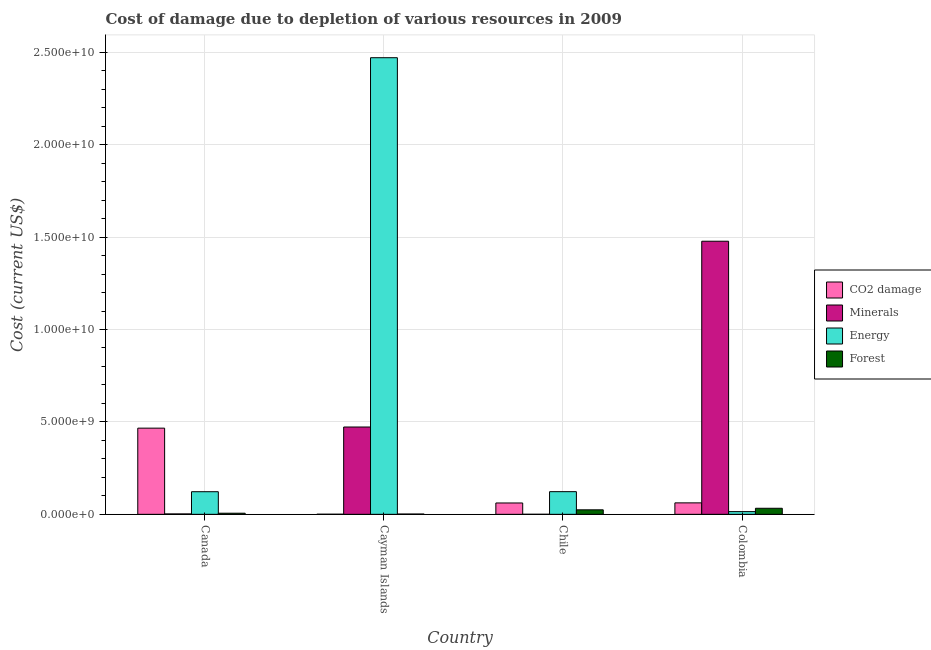Are the number of bars per tick equal to the number of legend labels?
Make the answer very short. Yes. Are the number of bars on each tick of the X-axis equal?
Ensure brevity in your answer.  Yes. How many bars are there on the 1st tick from the right?
Give a very brief answer. 4. What is the label of the 1st group of bars from the left?
Your response must be concise. Canada. What is the cost of damage due to depletion of minerals in Canada?
Your answer should be compact. 2.16e+07. Across all countries, what is the maximum cost of damage due to depletion of minerals?
Provide a short and direct response. 1.48e+1. Across all countries, what is the minimum cost of damage due to depletion of forests?
Offer a very short reply. 1.59e+07. What is the total cost of damage due to depletion of minerals in the graph?
Provide a succinct answer. 1.95e+1. What is the difference between the cost of damage due to depletion of minerals in Canada and that in Cayman Islands?
Your response must be concise. -4.70e+09. What is the difference between the cost of damage due to depletion of minerals in Cayman Islands and the cost of damage due to depletion of energy in Canada?
Your answer should be very brief. 3.50e+09. What is the average cost of damage due to depletion of forests per country?
Offer a terse response. 1.62e+08. What is the difference between the cost of damage due to depletion of energy and cost of damage due to depletion of minerals in Cayman Islands?
Provide a short and direct response. 2.00e+1. What is the ratio of the cost of damage due to depletion of energy in Canada to that in Colombia?
Ensure brevity in your answer.  8.36. What is the difference between the highest and the second highest cost of damage due to depletion of minerals?
Provide a succinct answer. 1.01e+1. What is the difference between the highest and the lowest cost of damage due to depletion of energy?
Offer a terse response. 2.46e+1. In how many countries, is the cost of damage due to depletion of minerals greater than the average cost of damage due to depletion of minerals taken over all countries?
Offer a terse response. 1. Is the sum of the cost of damage due to depletion of coal in Canada and Colombia greater than the maximum cost of damage due to depletion of minerals across all countries?
Provide a succinct answer. No. Is it the case that in every country, the sum of the cost of damage due to depletion of minerals and cost of damage due to depletion of coal is greater than the sum of cost of damage due to depletion of energy and cost of damage due to depletion of forests?
Your response must be concise. Yes. What does the 4th bar from the left in Chile represents?
Offer a terse response. Forest. What does the 3rd bar from the right in Canada represents?
Your answer should be compact. Minerals. Is it the case that in every country, the sum of the cost of damage due to depletion of coal and cost of damage due to depletion of minerals is greater than the cost of damage due to depletion of energy?
Offer a terse response. No. Are all the bars in the graph horizontal?
Provide a short and direct response. No. How many countries are there in the graph?
Provide a succinct answer. 4. What is the difference between two consecutive major ticks on the Y-axis?
Offer a terse response. 5.00e+09. Are the values on the major ticks of Y-axis written in scientific E-notation?
Offer a terse response. Yes. Does the graph contain any zero values?
Offer a terse response. No. Does the graph contain grids?
Ensure brevity in your answer.  Yes. How are the legend labels stacked?
Provide a succinct answer. Vertical. What is the title of the graph?
Your answer should be compact. Cost of damage due to depletion of various resources in 2009 . What is the label or title of the X-axis?
Offer a very short reply. Country. What is the label or title of the Y-axis?
Make the answer very short. Cost (current US$). What is the Cost (current US$) of CO2 damage in Canada?
Provide a short and direct response. 4.66e+09. What is the Cost (current US$) of Minerals in Canada?
Your answer should be compact. 2.16e+07. What is the Cost (current US$) in Energy in Canada?
Give a very brief answer. 1.22e+09. What is the Cost (current US$) of Forest in Canada?
Keep it short and to the point. 5.99e+07. What is the Cost (current US$) in CO2 damage in Cayman Islands?
Give a very brief answer. 5.15e+06. What is the Cost (current US$) in Minerals in Cayman Islands?
Offer a terse response. 4.72e+09. What is the Cost (current US$) in Energy in Cayman Islands?
Make the answer very short. 2.47e+1. What is the Cost (current US$) of Forest in Cayman Islands?
Offer a terse response. 1.59e+07. What is the Cost (current US$) in CO2 damage in Chile?
Provide a succinct answer. 6.14e+08. What is the Cost (current US$) of Minerals in Chile?
Make the answer very short. 1.43e+06. What is the Cost (current US$) in Energy in Chile?
Offer a terse response. 1.23e+09. What is the Cost (current US$) of Forest in Chile?
Offer a very short reply. 2.43e+08. What is the Cost (current US$) in CO2 damage in Colombia?
Make the answer very short. 6.20e+08. What is the Cost (current US$) of Minerals in Colombia?
Provide a short and direct response. 1.48e+1. What is the Cost (current US$) of Energy in Colombia?
Make the answer very short. 1.46e+08. What is the Cost (current US$) in Forest in Colombia?
Provide a short and direct response. 3.27e+08. Across all countries, what is the maximum Cost (current US$) of CO2 damage?
Your response must be concise. 4.66e+09. Across all countries, what is the maximum Cost (current US$) in Minerals?
Make the answer very short. 1.48e+1. Across all countries, what is the maximum Cost (current US$) in Energy?
Provide a short and direct response. 2.47e+1. Across all countries, what is the maximum Cost (current US$) of Forest?
Make the answer very short. 3.27e+08. Across all countries, what is the minimum Cost (current US$) in CO2 damage?
Provide a succinct answer. 5.15e+06. Across all countries, what is the minimum Cost (current US$) of Minerals?
Provide a short and direct response. 1.43e+06. Across all countries, what is the minimum Cost (current US$) in Energy?
Make the answer very short. 1.46e+08. Across all countries, what is the minimum Cost (current US$) in Forest?
Offer a terse response. 1.59e+07. What is the total Cost (current US$) of CO2 damage in the graph?
Provide a succinct answer. 5.90e+09. What is the total Cost (current US$) in Minerals in the graph?
Your answer should be very brief. 1.95e+1. What is the total Cost (current US$) of Energy in the graph?
Offer a very short reply. 2.73e+1. What is the total Cost (current US$) in Forest in the graph?
Your answer should be very brief. 6.46e+08. What is the difference between the Cost (current US$) of CO2 damage in Canada and that in Cayman Islands?
Your answer should be very brief. 4.66e+09. What is the difference between the Cost (current US$) in Minerals in Canada and that in Cayman Islands?
Offer a very short reply. -4.70e+09. What is the difference between the Cost (current US$) in Energy in Canada and that in Cayman Islands?
Your answer should be compact. -2.35e+1. What is the difference between the Cost (current US$) in Forest in Canada and that in Cayman Islands?
Your response must be concise. 4.40e+07. What is the difference between the Cost (current US$) in CO2 damage in Canada and that in Chile?
Provide a succinct answer. 4.05e+09. What is the difference between the Cost (current US$) in Minerals in Canada and that in Chile?
Your answer should be compact. 2.02e+07. What is the difference between the Cost (current US$) in Energy in Canada and that in Chile?
Your response must be concise. -2.40e+06. What is the difference between the Cost (current US$) in Forest in Canada and that in Chile?
Make the answer very short. -1.83e+08. What is the difference between the Cost (current US$) of CO2 damage in Canada and that in Colombia?
Give a very brief answer. 4.04e+09. What is the difference between the Cost (current US$) in Minerals in Canada and that in Colombia?
Provide a short and direct response. -1.48e+1. What is the difference between the Cost (current US$) in Energy in Canada and that in Colombia?
Ensure brevity in your answer.  1.08e+09. What is the difference between the Cost (current US$) of Forest in Canada and that in Colombia?
Make the answer very short. -2.67e+08. What is the difference between the Cost (current US$) of CO2 damage in Cayman Islands and that in Chile?
Keep it short and to the point. -6.09e+08. What is the difference between the Cost (current US$) in Minerals in Cayman Islands and that in Chile?
Ensure brevity in your answer.  4.72e+09. What is the difference between the Cost (current US$) of Energy in Cayman Islands and that in Chile?
Give a very brief answer. 2.35e+1. What is the difference between the Cost (current US$) of Forest in Cayman Islands and that in Chile?
Make the answer very short. -2.28e+08. What is the difference between the Cost (current US$) of CO2 damage in Cayman Islands and that in Colombia?
Offer a very short reply. -6.14e+08. What is the difference between the Cost (current US$) in Minerals in Cayman Islands and that in Colombia?
Make the answer very short. -1.01e+1. What is the difference between the Cost (current US$) of Energy in Cayman Islands and that in Colombia?
Keep it short and to the point. 2.46e+1. What is the difference between the Cost (current US$) in Forest in Cayman Islands and that in Colombia?
Your answer should be compact. -3.11e+08. What is the difference between the Cost (current US$) of CO2 damage in Chile and that in Colombia?
Keep it short and to the point. -5.76e+06. What is the difference between the Cost (current US$) of Minerals in Chile and that in Colombia?
Provide a succinct answer. -1.48e+1. What is the difference between the Cost (current US$) in Energy in Chile and that in Colombia?
Ensure brevity in your answer.  1.08e+09. What is the difference between the Cost (current US$) in Forest in Chile and that in Colombia?
Keep it short and to the point. -8.34e+07. What is the difference between the Cost (current US$) in CO2 damage in Canada and the Cost (current US$) in Minerals in Cayman Islands?
Provide a succinct answer. -6.16e+07. What is the difference between the Cost (current US$) of CO2 damage in Canada and the Cost (current US$) of Energy in Cayman Islands?
Offer a terse response. -2.00e+1. What is the difference between the Cost (current US$) of CO2 damage in Canada and the Cost (current US$) of Forest in Cayman Islands?
Provide a short and direct response. 4.65e+09. What is the difference between the Cost (current US$) of Minerals in Canada and the Cost (current US$) of Energy in Cayman Islands?
Provide a succinct answer. -2.47e+1. What is the difference between the Cost (current US$) of Minerals in Canada and the Cost (current US$) of Forest in Cayman Islands?
Provide a succinct answer. 5.75e+06. What is the difference between the Cost (current US$) of Energy in Canada and the Cost (current US$) of Forest in Cayman Islands?
Give a very brief answer. 1.21e+09. What is the difference between the Cost (current US$) of CO2 damage in Canada and the Cost (current US$) of Minerals in Chile?
Provide a succinct answer. 4.66e+09. What is the difference between the Cost (current US$) in CO2 damage in Canada and the Cost (current US$) in Energy in Chile?
Provide a succinct answer. 3.44e+09. What is the difference between the Cost (current US$) of CO2 damage in Canada and the Cost (current US$) of Forest in Chile?
Your answer should be very brief. 4.42e+09. What is the difference between the Cost (current US$) in Minerals in Canada and the Cost (current US$) in Energy in Chile?
Your response must be concise. -1.20e+09. What is the difference between the Cost (current US$) of Minerals in Canada and the Cost (current US$) of Forest in Chile?
Your answer should be very brief. -2.22e+08. What is the difference between the Cost (current US$) in Energy in Canada and the Cost (current US$) in Forest in Chile?
Provide a short and direct response. 9.80e+08. What is the difference between the Cost (current US$) in CO2 damage in Canada and the Cost (current US$) in Minerals in Colombia?
Provide a short and direct response. -1.01e+1. What is the difference between the Cost (current US$) in CO2 damage in Canada and the Cost (current US$) in Energy in Colombia?
Your answer should be very brief. 4.52e+09. What is the difference between the Cost (current US$) of CO2 damage in Canada and the Cost (current US$) of Forest in Colombia?
Keep it short and to the point. 4.34e+09. What is the difference between the Cost (current US$) in Minerals in Canada and the Cost (current US$) in Energy in Colombia?
Give a very brief answer. -1.25e+08. What is the difference between the Cost (current US$) of Minerals in Canada and the Cost (current US$) of Forest in Colombia?
Give a very brief answer. -3.05e+08. What is the difference between the Cost (current US$) in Energy in Canada and the Cost (current US$) in Forest in Colombia?
Keep it short and to the point. 8.97e+08. What is the difference between the Cost (current US$) in CO2 damage in Cayman Islands and the Cost (current US$) in Minerals in Chile?
Provide a short and direct response. 3.73e+06. What is the difference between the Cost (current US$) of CO2 damage in Cayman Islands and the Cost (current US$) of Energy in Chile?
Keep it short and to the point. -1.22e+09. What is the difference between the Cost (current US$) of CO2 damage in Cayman Islands and the Cost (current US$) of Forest in Chile?
Your answer should be very brief. -2.38e+08. What is the difference between the Cost (current US$) in Minerals in Cayman Islands and the Cost (current US$) in Energy in Chile?
Offer a very short reply. 3.50e+09. What is the difference between the Cost (current US$) in Minerals in Cayman Islands and the Cost (current US$) in Forest in Chile?
Provide a succinct answer. 4.48e+09. What is the difference between the Cost (current US$) in Energy in Cayman Islands and the Cost (current US$) in Forest in Chile?
Your answer should be very brief. 2.45e+1. What is the difference between the Cost (current US$) in CO2 damage in Cayman Islands and the Cost (current US$) in Minerals in Colombia?
Ensure brevity in your answer.  -1.48e+1. What is the difference between the Cost (current US$) of CO2 damage in Cayman Islands and the Cost (current US$) of Energy in Colombia?
Provide a succinct answer. -1.41e+08. What is the difference between the Cost (current US$) of CO2 damage in Cayman Islands and the Cost (current US$) of Forest in Colombia?
Provide a succinct answer. -3.22e+08. What is the difference between the Cost (current US$) in Minerals in Cayman Islands and the Cost (current US$) in Energy in Colombia?
Provide a succinct answer. 4.58e+09. What is the difference between the Cost (current US$) of Minerals in Cayman Islands and the Cost (current US$) of Forest in Colombia?
Provide a short and direct response. 4.40e+09. What is the difference between the Cost (current US$) in Energy in Cayman Islands and the Cost (current US$) in Forest in Colombia?
Your answer should be compact. 2.44e+1. What is the difference between the Cost (current US$) in CO2 damage in Chile and the Cost (current US$) in Minerals in Colombia?
Your response must be concise. -1.42e+1. What is the difference between the Cost (current US$) of CO2 damage in Chile and the Cost (current US$) of Energy in Colombia?
Offer a very short reply. 4.68e+08. What is the difference between the Cost (current US$) in CO2 damage in Chile and the Cost (current US$) in Forest in Colombia?
Ensure brevity in your answer.  2.87e+08. What is the difference between the Cost (current US$) in Minerals in Chile and the Cost (current US$) in Energy in Colombia?
Ensure brevity in your answer.  -1.45e+08. What is the difference between the Cost (current US$) of Minerals in Chile and the Cost (current US$) of Forest in Colombia?
Give a very brief answer. -3.25e+08. What is the difference between the Cost (current US$) of Energy in Chile and the Cost (current US$) of Forest in Colombia?
Provide a succinct answer. 8.99e+08. What is the average Cost (current US$) in CO2 damage per country?
Your answer should be compact. 1.48e+09. What is the average Cost (current US$) in Minerals per country?
Keep it short and to the point. 4.88e+09. What is the average Cost (current US$) of Energy per country?
Provide a succinct answer. 6.83e+09. What is the average Cost (current US$) of Forest per country?
Offer a terse response. 1.62e+08. What is the difference between the Cost (current US$) of CO2 damage and Cost (current US$) of Minerals in Canada?
Provide a succinct answer. 4.64e+09. What is the difference between the Cost (current US$) of CO2 damage and Cost (current US$) of Energy in Canada?
Ensure brevity in your answer.  3.44e+09. What is the difference between the Cost (current US$) in CO2 damage and Cost (current US$) in Forest in Canada?
Give a very brief answer. 4.60e+09. What is the difference between the Cost (current US$) of Minerals and Cost (current US$) of Energy in Canada?
Offer a very short reply. -1.20e+09. What is the difference between the Cost (current US$) of Minerals and Cost (current US$) of Forest in Canada?
Provide a short and direct response. -3.83e+07. What is the difference between the Cost (current US$) in Energy and Cost (current US$) in Forest in Canada?
Give a very brief answer. 1.16e+09. What is the difference between the Cost (current US$) of CO2 damage and Cost (current US$) of Minerals in Cayman Islands?
Provide a short and direct response. -4.72e+09. What is the difference between the Cost (current US$) of CO2 damage and Cost (current US$) of Energy in Cayman Islands?
Keep it short and to the point. -2.47e+1. What is the difference between the Cost (current US$) of CO2 damage and Cost (current US$) of Forest in Cayman Islands?
Offer a terse response. -1.07e+07. What is the difference between the Cost (current US$) of Minerals and Cost (current US$) of Energy in Cayman Islands?
Make the answer very short. -2.00e+1. What is the difference between the Cost (current US$) in Minerals and Cost (current US$) in Forest in Cayman Islands?
Your answer should be compact. 4.71e+09. What is the difference between the Cost (current US$) of Energy and Cost (current US$) of Forest in Cayman Islands?
Provide a succinct answer. 2.47e+1. What is the difference between the Cost (current US$) of CO2 damage and Cost (current US$) of Minerals in Chile?
Provide a short and direct response. 6.12e+08. What is the difference between the Cost (current US$) in CO2 damage and Cost (current US$) in Energy in Chile?
Provide a succinct answer. -6.12e+08. What is the difference between the Cost (current US$) of CO2 damage and Cost (current US$) of Forest in Chile?
Provide a short and direct response. 3.70e+08. What is the difference between the Cost (current US$) of Minerals and Cost (current US$) of Energy in Chile?
Your answer should be very brief. -1.22e+09. What is the difference between the Cost (current US$) of Minerals and Cost (current US$) of Forest in Chile?
Give a very brief answer. -2.42e+08. What is the difference between the Cost (current US$) of Energy and Cost (current US$) of Forest in Chile?
Your answer should be compact. 9.82e+08. What is the difference between the Cost (current US$) of CO2 damage and Cost (current US$) of Minerals in Colombia?
Your answer should be very brief. -1.42e+1. What is the difference between the Cost (current US$) in CO2 damage and Cost (current US$) in Energy in Colombia?
Make the answer very short. 4.73e+08. What is the difference between the Cost (current US$) of CO2 damage and Cost (current US$) of Forest in Colombia?
Give a very brief answer. 2.93e+08. What is the difference between the Cost (current US$) in Minerals and Cost (current US$) in Energy in Colombia?
Keep it short and to the point. 1.46e+1. What is the difference between the Cost (current US$) in Minerals and Cost (current US$) in Forest in Colombia?
Provide a short and direct response. 1.44e+1. What is the difference between the Cost (current US$) of Energy and Cost (current US$) of Forest in Colombia?
Offer a very short reply. -1.81e+08. What is the ratio of the Cost (current US$) in CO2 damage in Canada to that in Cayman Islands?
Give a very brief answer. 904.42. What is the ratio of the Cost (current US$) of Minerals in Canada to that in Cayman Islands?
Ensure brevity in your answer.  0. What is the ratio of the Cost (current US$) in Energy in Canada to that in Cayman Islands?
Make the answer very short. 0.05. What is the ratio of the Cost (current US$) in Forest in Canada to that in Cayman Islands?
Keep it short and to the point. 3.77. What is the ratio of the Cost (current US$) in CO2 damage in Canada to that in Chile?
Your response must be concise. 7.6. What is the ratio of the Cost (current US$) in Minerals in Canada to that in Chile?
Give a very brief answer. 15.16. What is the ratio of the Cost (current US$) of Forest in Canada to that in Chile?
Give a very brief answer. 0.25. What is the ratio of the Cost (current US$) in CO2 damage in Canada to that in Colombia?
Your response must be concise. 7.52. What is the ratio of the Cost (current US$) of Minerals in Canada to that in Colombia?
Make the answer very short. 0. What is the ratio of the Cost (current US$) in Energy in Canada to that in Colombia?
Keep it short and to the point. 8.36. What is the ratio of the Cost (current US$) of Forest in Canada to that in Colombia?
Offer a terse response. 0.18. What is the ratio of the Cost (current US$) of CO2 damage in Cayman Islands to that in Chile?
Give a very brief answer. 0.01. What is the ratio of the Cost (current US$) in Minerals in Cayman Islands to that in Chile?
Your response must be concise. 3310.1. What is the ratio of the Cost (current US$) in Energy in Cayman Islands to that in Chile?
Your response must be concise. 20.15. What is the ratio of the Cost (current US$) of Forest in Cayman Islands to that in Chile?
Offer a terse response. 0.07. What is the ratio of the Cost (current US$) of CO2 damage in Cayman Islands to that in Colombia?
Your response must be concise. 0.01. What is the ratio of the Cost (current US$) of Minerals in Cayman Islands to that in Colombia?
Give a very brief answer. 0.32. What is the ratio of the Cost (current US$) in Energy in Cayman Islands to that in Colombia?
Your answer should be compact. 168.89. What is the ratio of the Cost (current US$) of Forest in Cayman Islands to that in Colombia?
Your answer should be compact. 0.05. What is the ratio of the Cost (current US$) of Minerals in Chile to that in Colombia?
Keep it short and to the point. 0. What is the ratio of the Cost (current US$) in Energy in Chile to that in Colombia?
Your answer should be very brief. 8.38. What is the ratio of the Cost (current US$) of Forest in Chile to that in Colombia?
Keep it short and to the point. 0.74. What is the difference between the highest and the second highest Cost (current US$) of CO2 damage?
Ensure brevity in your answer.  4.04e+09. What is the difference between the highest and the second highest Cost (current US$) in Minerals?
Provide a succinct answer. 1.01e+1. What is the difference between the highest and the second highest Cost (current US$) of Energy?
Provide a succinct answer. 2.35e+1. What is the difference between the highest and the second highest Cost (current US$) in Forest?
Provide a succinct answer. 8.34e+07. What is the difference between the highest and the lowest Cost (current US$) in CO2 damage?
Your answer should be compact. 4.66e+09. What is the difference between the highest and the lowest Cost (current US$) of Minerals?
Keep it short and to the point. 1.48e+1. What is the difference between the highest and the lowest Cost (current US$) of Energy?
Provide a succinct answer. 2.46e+1. What is the difference between the highest and the lowest Cost (current US$) of Forest?
Give a very brief answer. 3.11e+08. 